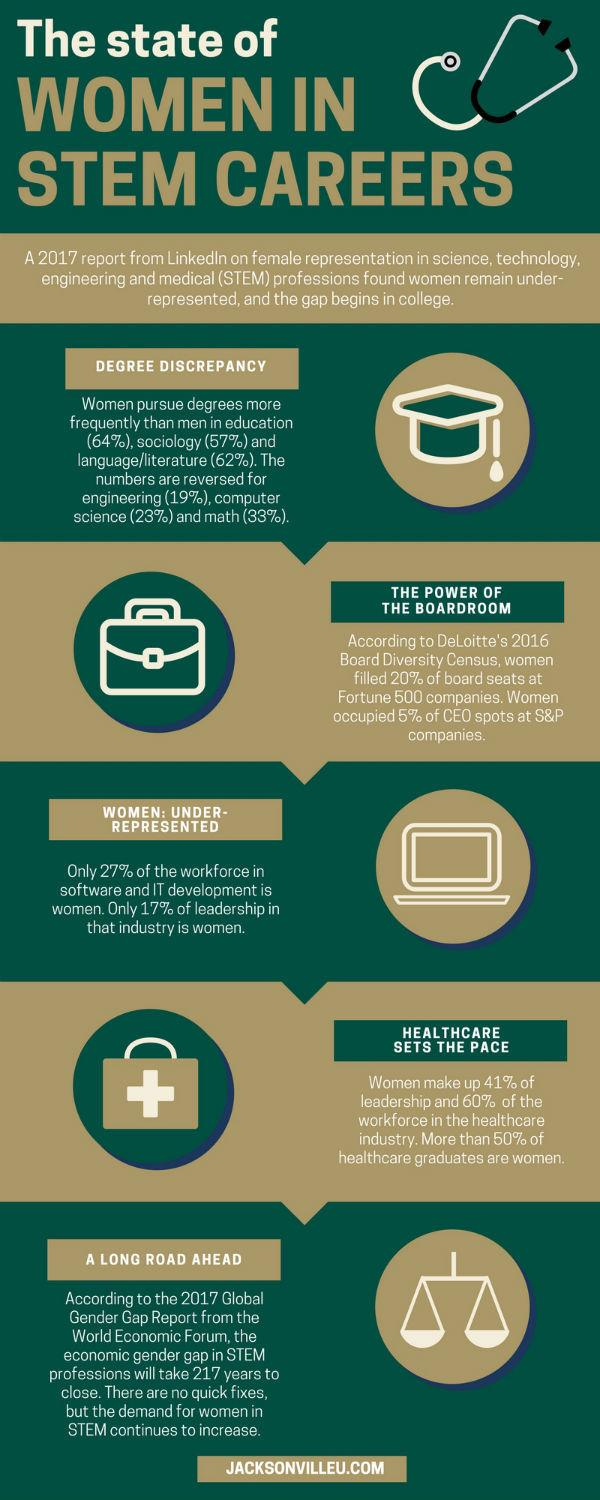Draw attention to some important aspects in this diagram. According to a recent survey, a significant majority of leadership positions in the healthcare industry are held by men, with only 41% being held by women. This statistic indicates a need for greater gender diversity and inclusion in leadership roles within the healthcare industry. According to a recent survey, approximately 40% of the workforce in the healthcare industry is not comprised of women. Ninety-five percent of CEO positions at S&P companies are not held by women. A significant majority of the workforce in software and IT development is comprised of men, with 73% of workers in this field being male. According to a recent study, 80% of the board seats at Fortune 500 companies are held by men, indicating a significant disparity in gender representation in leadership positions. 